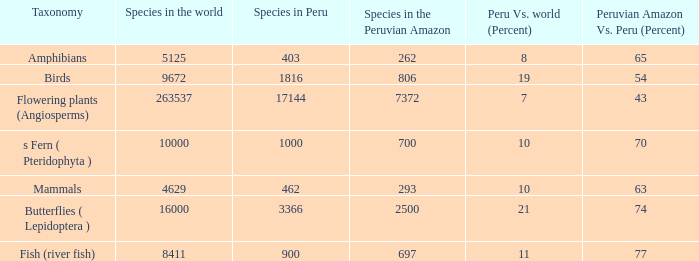Considering 8411 species worldwide, what is the cumulative number of species in the peruvian amazon? 1.0. 